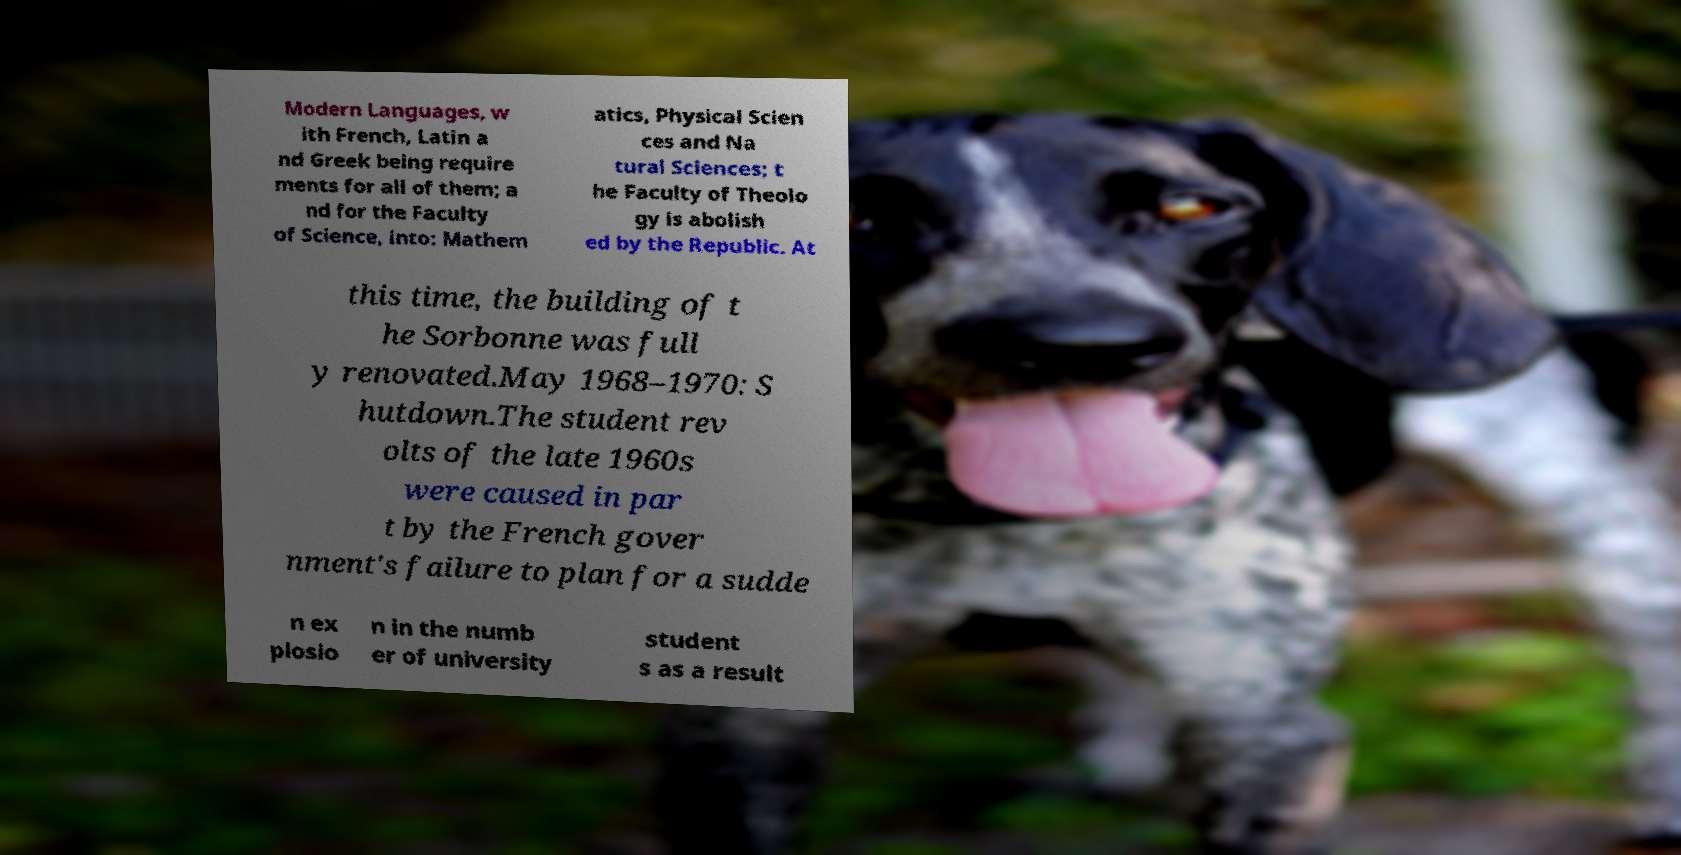Can you read and provide the text displayed in the image?This photo seems to have some interesting text. Can you extract and type it out for me? Modern Languages, w ith French, Latin a nd Greek being require ments for all of them; a nd for the Faculty of Science, into: Mathem atics, Physical Scien ces and Na tural Sciences; t he Faculty of Theolo gy is abolish ed by the Republic. At this time, the building of t he Sorbonne was full y renovated.May 1968–1970: S hutdown.The student rev olts of the late 1960s were caused in par t by the French gover nment's failure to plan for a sudde n ex plosio n in the numb er of university student s as a result 